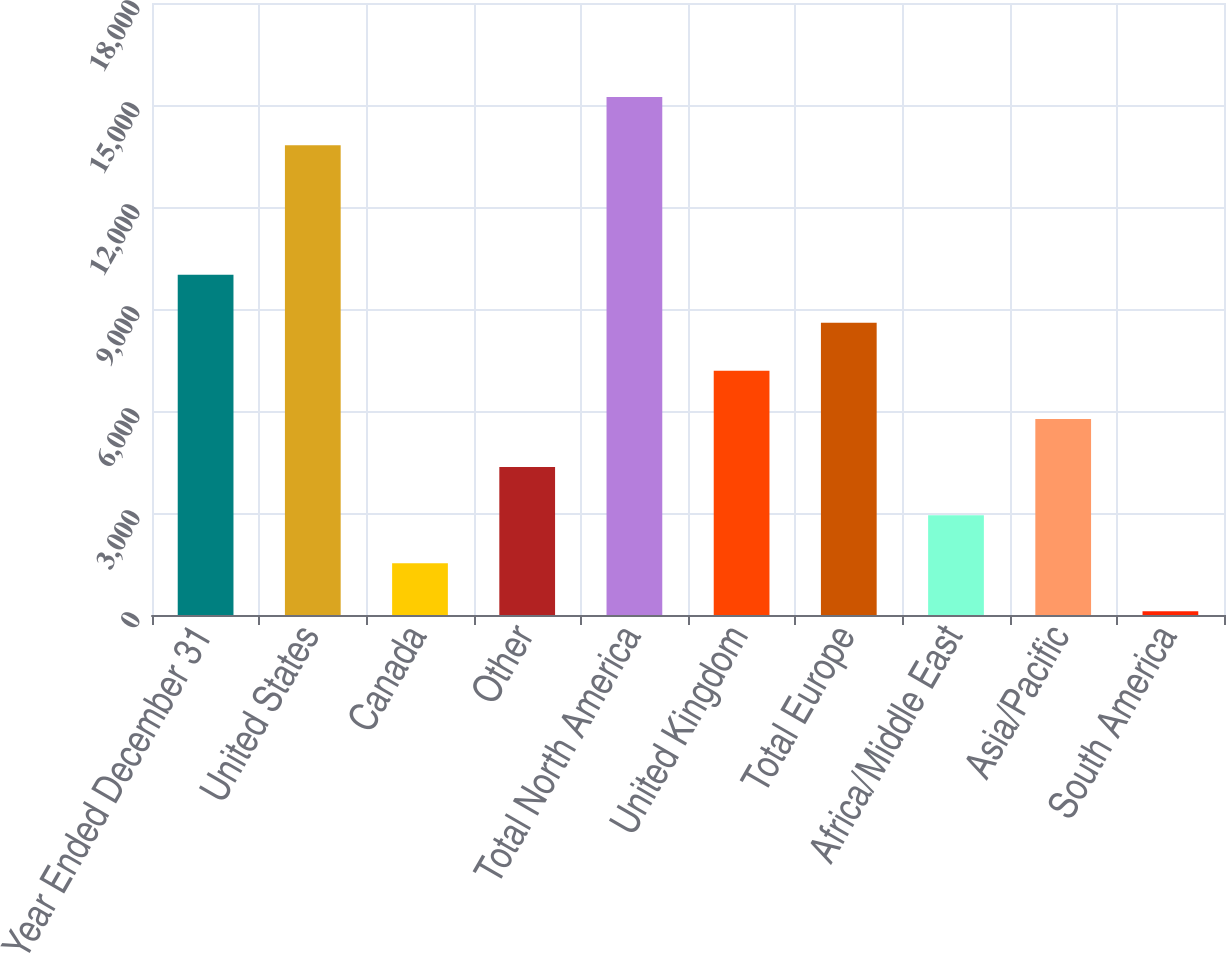Convert chart to OTSL. <chart><loc_0><loc_0><loc_500><loc_500><bar_chart><fcel>Year Ended December 31<fcel>United States<fcel>Canada<fcel>Other<fcel>Total North America<fcel>United Kingdom<fcel>Total Europe<fcel>Africa/Middle East<fcel>Asia/Pacific<fcel>South America<nl><fcel>10009.9<fcel>13817<fcel>1521.7<fcel>4351.1<fcel>15231.7<fcel>7180.5<fcel>8595.2<fcel>2936.4<fcel>5765.8<fcel>107<nl></chart> 